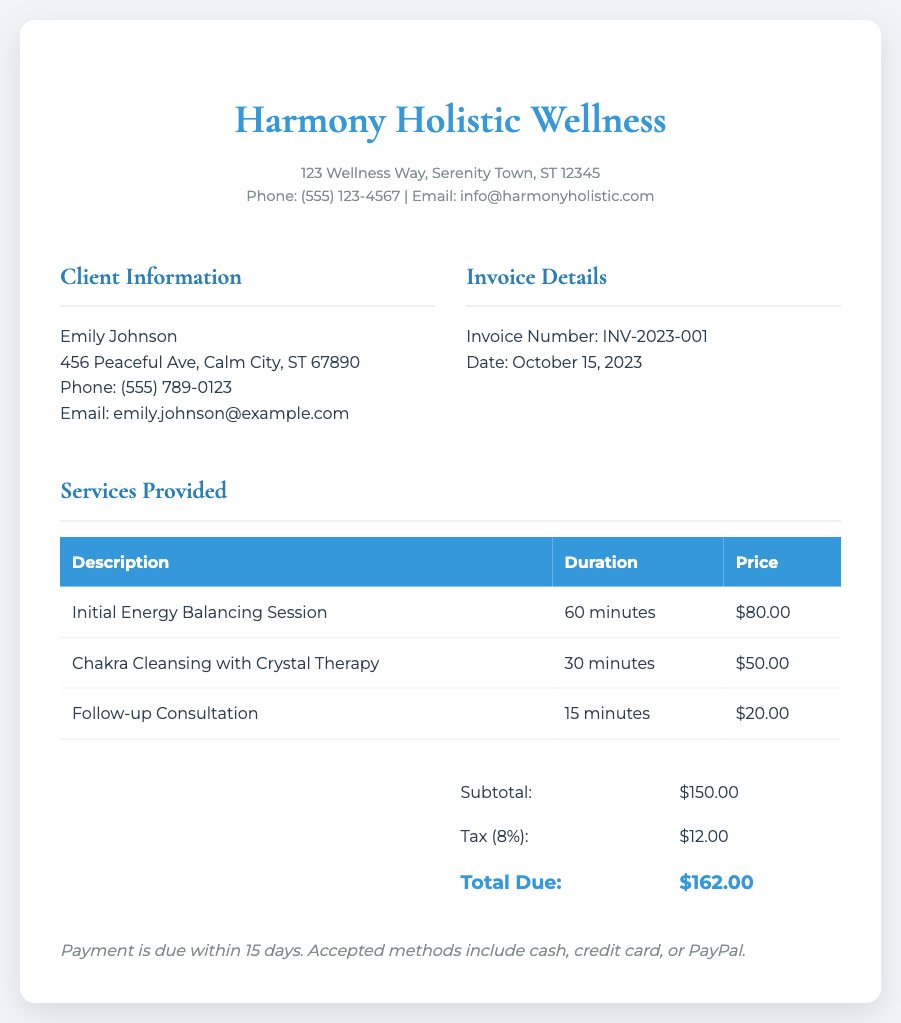What is the client’s name? The document specifies the client's name in the client information section.
Answer: Emily Johnson What is the invoice number? The invoice number is clearly stated in the invoice details section.
Answer: INV-2023-001 What is the total amount due? The total due is indicated in the total section of the invoice.
Answer: $162.00 What is the tax percentage applied? The tax percentage is listed in the total section of the invoice before the total due amount.
Answer: 8% How long is the Initial Energy Balancing Session? The duration of the Initial Energy Balancing Session is mentioned in the services provided table.
Answer: 60 minutes What service costs $50.00? The service costing $50.00 is specified in the services provided table.
Answer: Chakra Cleansing with Crystal Therapy How many different services are listed in the invoice? The number of different services can be counted in the services provided section of the document.
Answer: 3 When is the payment due? The payment terms state when payment should be settled, which is mentioned in the payment terms section.
Answer: Within 15 days What are the accepted payment methods? The accepted methods of payment are clearly listed under the payment terms.
Answer: Cash, credit card, or PayPal 